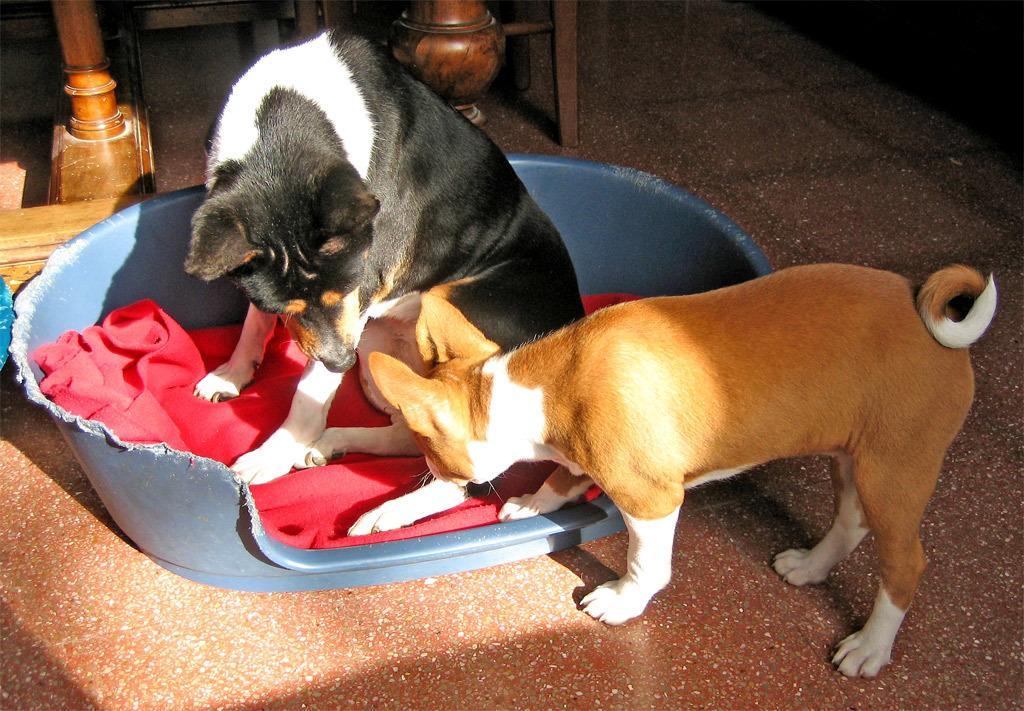Please provide a concise description of this image. In this image we can see two dogs and among them a dog is sitting on a red cloth. The cloth is placed in a tub. At the top we can see wooden objects. 